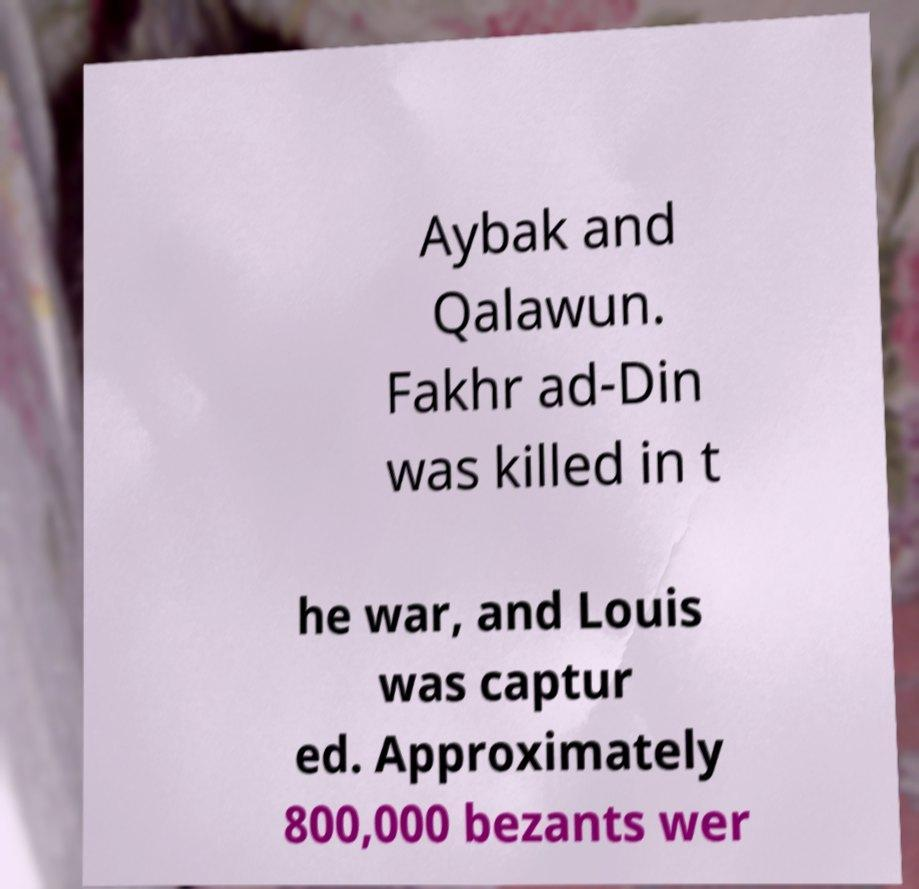Could you assist in decoding the text presented in this image and type it out clearly? Aybak and Qalawun. Fakhr ad-Din was killed in t he war, and Louis was captur ed. Approximately 800,000 bezants wer 